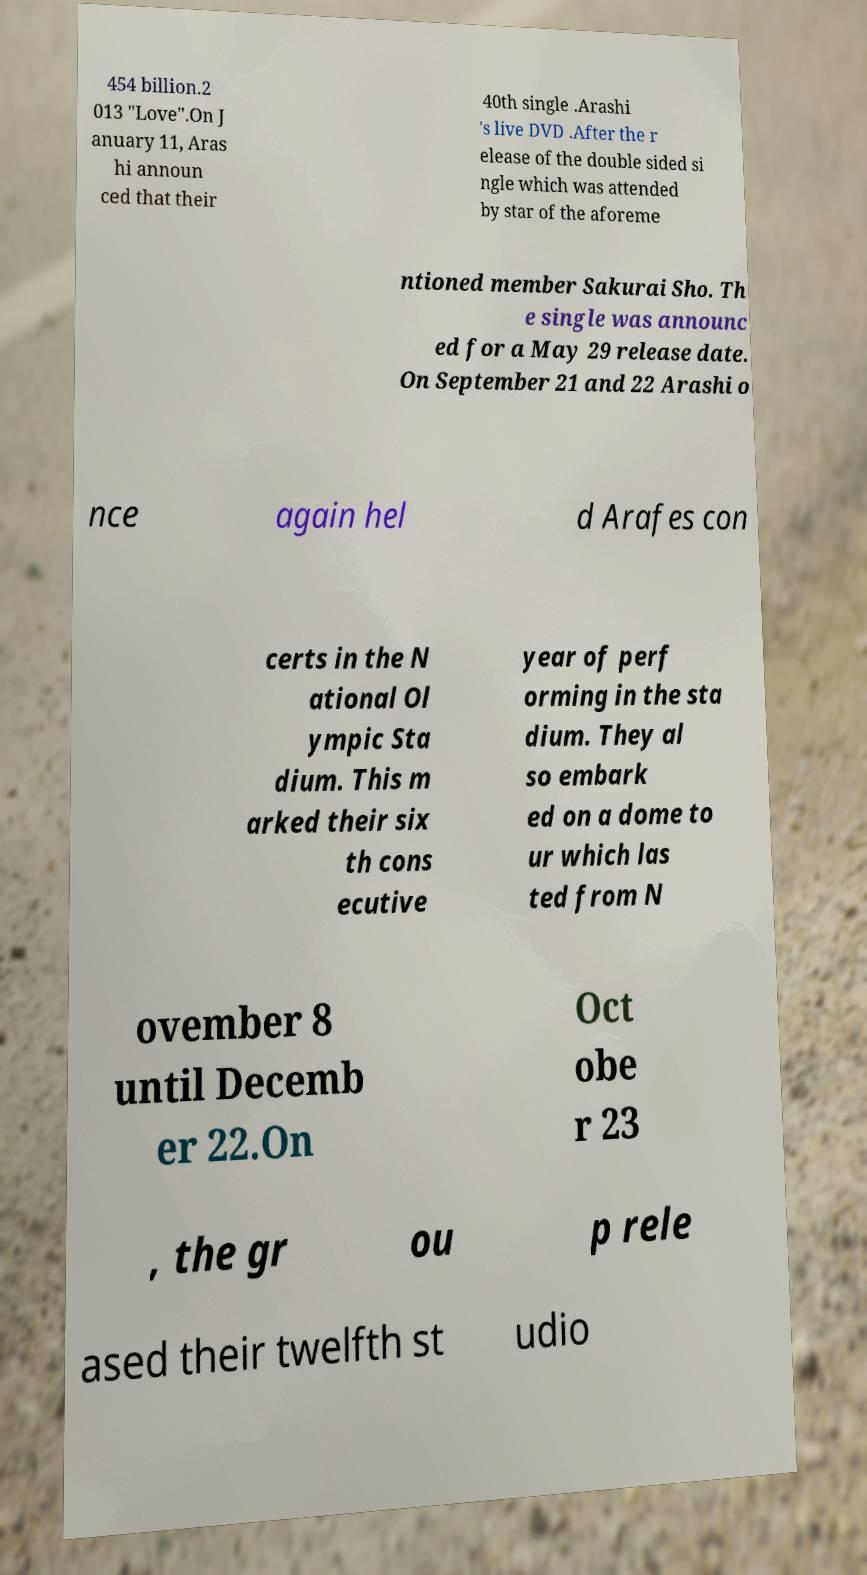There's text embedded in this image that I need extracted. Can you transcribe it verbatim? 454 billion.2 013 "Love".On J anuary 11, Aras hi announ ced that their 40th single .Arashi 's live DVD .After the r elease of the double sided si ngle which was attended by star of the aforeme ntioned member Sakurai Sho. Th e single was announc ed for a May 29 release date. On September 21 and 22 Arashi o nce again hel d Arafes con certs in the N ational Ol ympic Sta dium. This m arked their six th cons ecutive year of perf orming in the sta dium. They al so embark ed on a dome to ur which las ted from N ovember 8 until Decemb er 22.On Oct obe r 23 , the gr ou p rele ased their twelfth st udio 